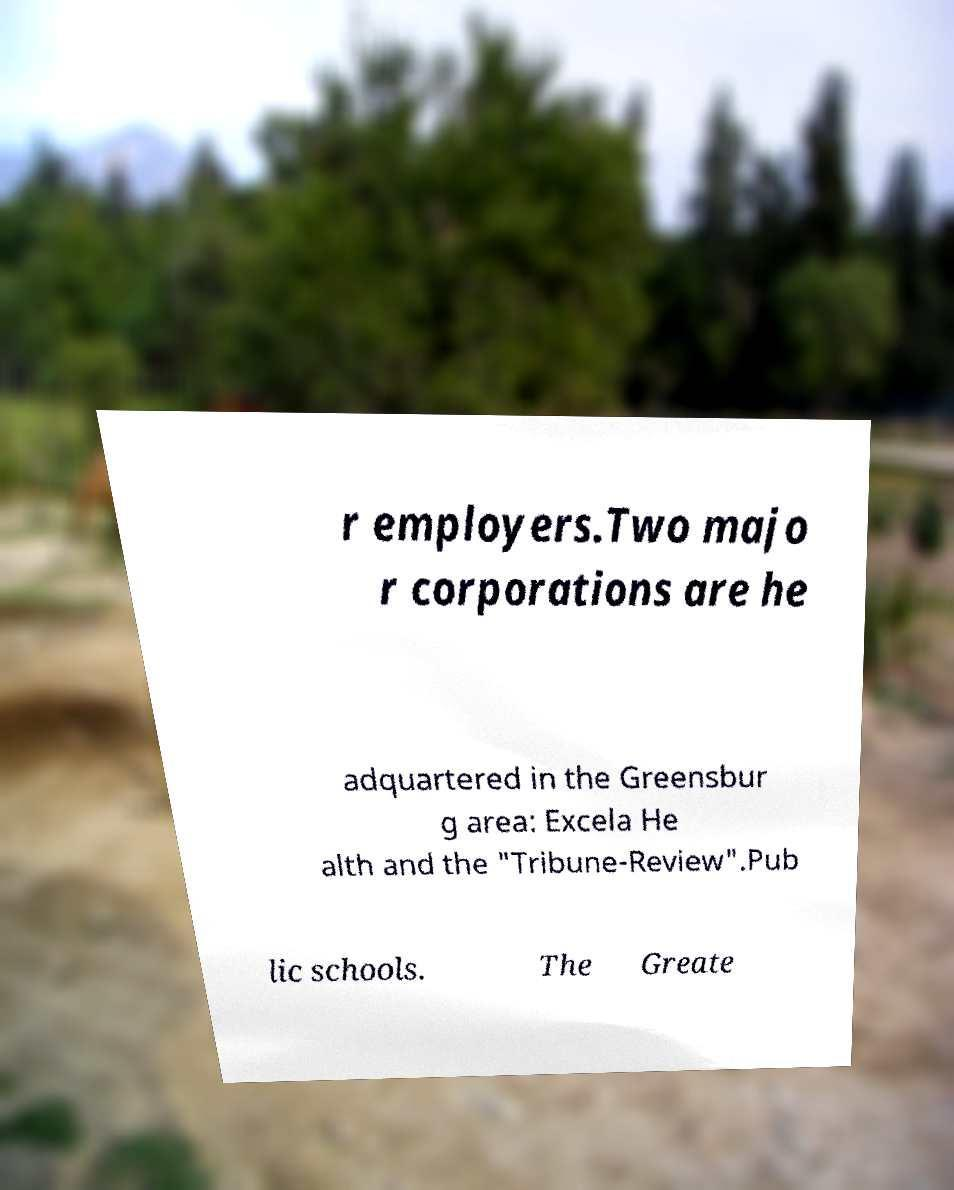For documentation purposes, I need the text within this image transcribed. Could you provide that? r employers.Two majo r corporations are he adquartered in the Greensbur g area: Excela He alth and the "Tribune-Review".Pub lic schools. The Greate 